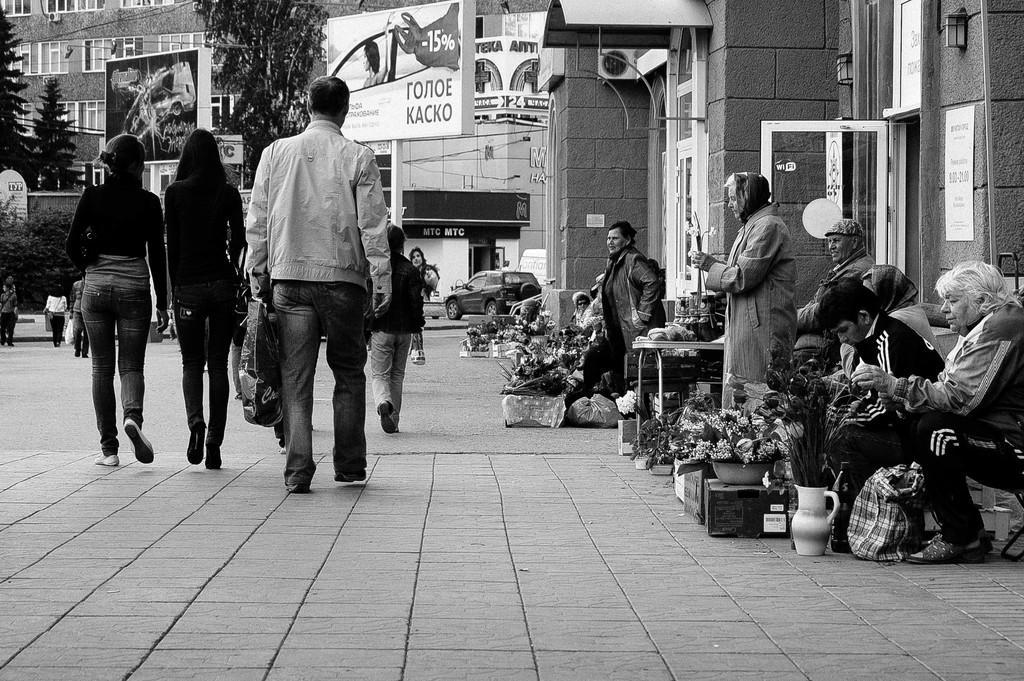Please provide a concise description of this image. In this picture there are group of people walking and there are group of standing and there are two persons standing and there are flowers vases and cardboard boxes and there are buildings, trees and there are boards on the buildings and there are vehicles on the road. There are lights and air conditioners on the wall. 